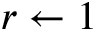Convert formula to latex. <formula><loc_0><loc_0><loc_500><loc_500>r \gets 1</formula> 